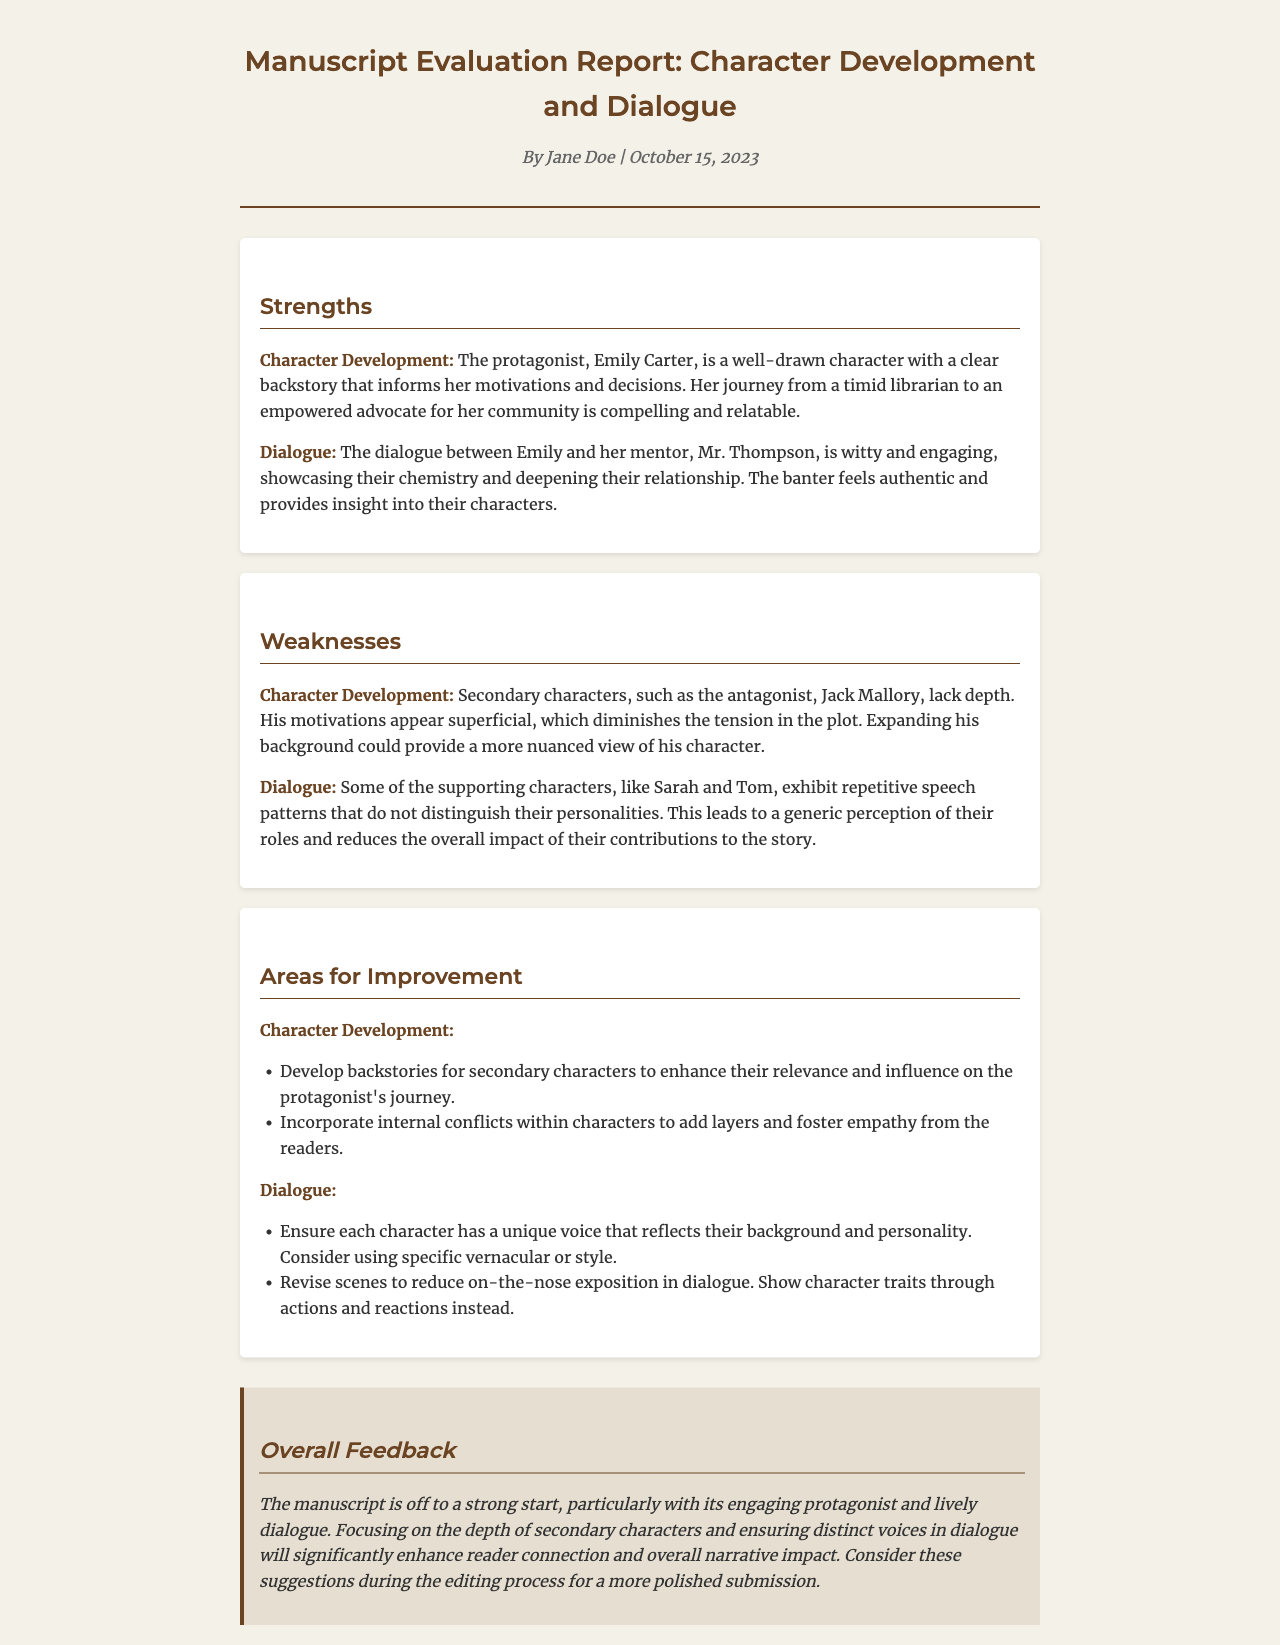What is the name of the protagonist? The protagonist is named Emily Carter, as stated in the strengths section of the report.
Answer: Emily Carter Who is Emily's mentor? The mentor of Emily Carter is mentioned as Mr. Thompson in the dialogue strengths overview.
Answer: Mr. Thompson What is one major weakness of the antagonist? The report indicates that the antagonist, Jack Mallory, lacks depth and has superficial motivations.
Answer: Lack of depth How many areas for improvement are listed for character development? Two areas for improvement are specifically mentioned for character development in the report.
Answer: Two What type of speech patterns do supporting characters exhibit? The report notes that supporting characters like Sarah and Tom display repetitive speech patterns.
Answer: Repetitive What is an improvement suggested for dialogue? The report suggests ensuring each character has a unique voice that reflects their background and personality.
Answer: Unique voice What is the overall feedback on the manuscript? The overall feedback indicates that the manuscript is off to a strong start but needs focus on secondary characters and dialogue.
Answer: Strong start When was this evaluation report authored? The report was authored on October 15, 2023, as stated below the title.
Answer: October 15, 2023 